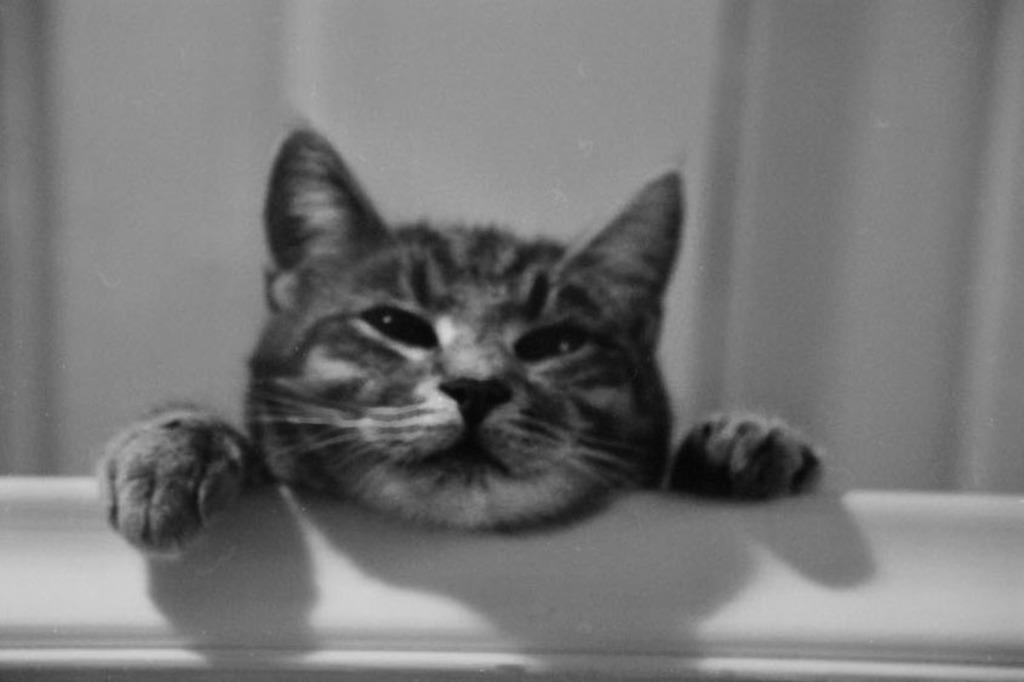What is the color scheme of the image? The image is black and white. What is the main subject of the image? There is a picture of a cat in the image. What color is the background of the image? The background of the image is white. What type of wool can be seen in the image? There is no wool present in the image. What smell is associated with the cat in the image? The image is in black and white, so it is not possible to determine the smell associated with the cat. 